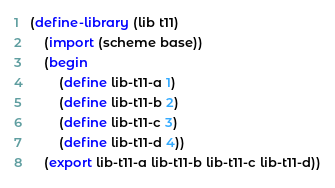Convert code to text. <code><loc_0><loc_0><loc_500><loc_500><_Scheme_>(define-library (lib t11)
    (import (scheme base))
    (begin
        (define lib-t11-a 1)
        (define lib-t11-b 2)
        (define lib-t11-c 3)
        (define lib-t11-d 4))
    (export lib-t11-a lib-t11-b lib-t11-c lib-t11-d))
</code> 